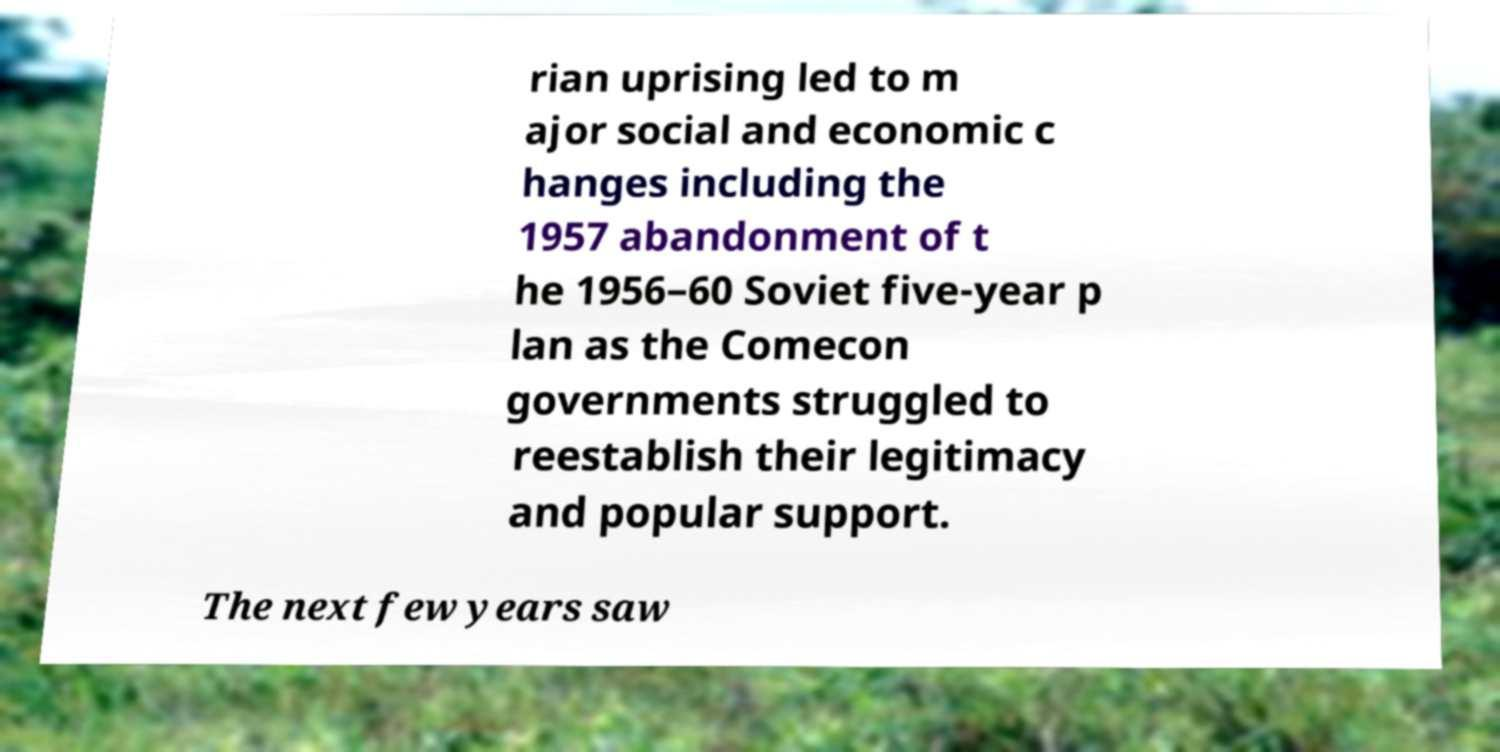For documentation purposes, I need the text within this image transcribed. Could you provide that? rian uprising led to m ajor social and economic c hanges including the 1957 abandonment of t he 1956–60 Soviet five-year p lan as the Comecon governments struggled to reestablish their legitimacy and popular support. The next few years saw 